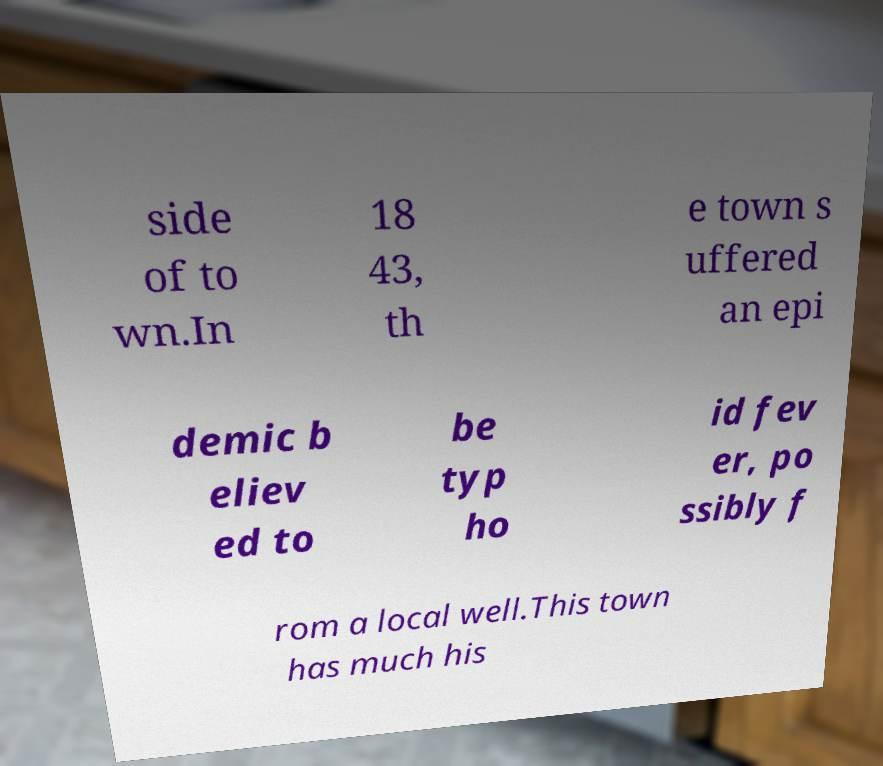Please read and relay the text visible in this image. What does it say? side of to wn.In 18 43, th e town s uffered an epi demic b eliev ed to be typ ho id fev er, po ssibly f rom a local well.This town has much his 